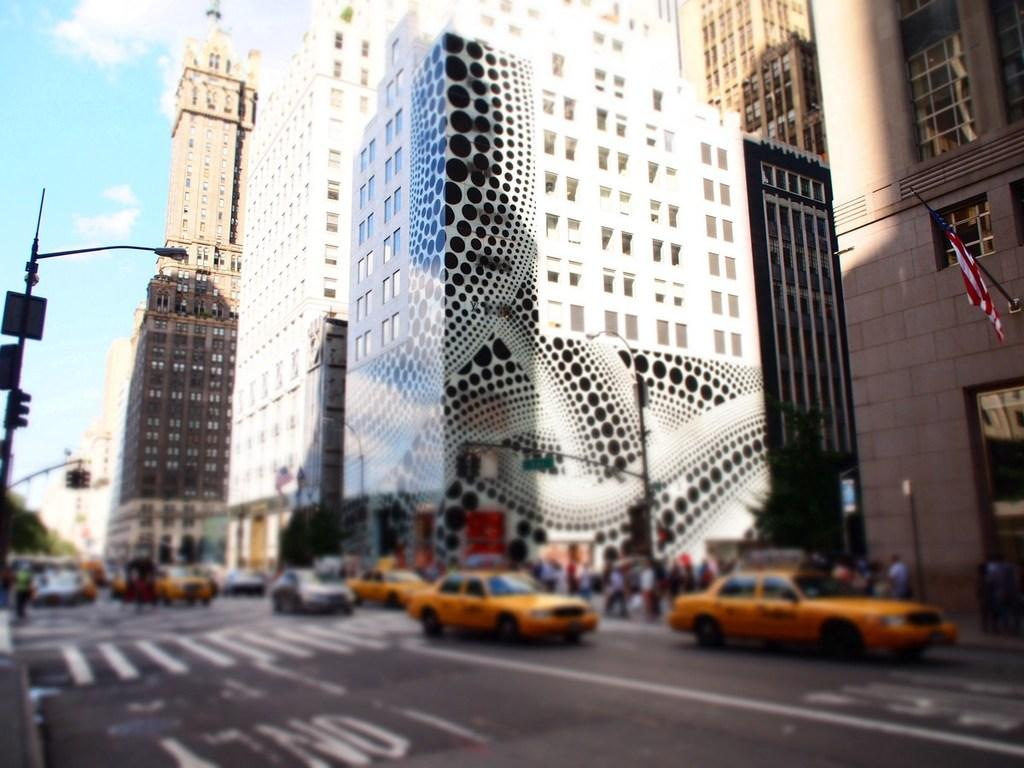What is the main feature of the image? There is a road in the image. What is happening on the road? There are cars on the road. What can be seen in the distance in the image? There are buildings in the background of the image. What type of thread is being used to create the verse on the plant in the image? There is no thread, verse, or plant present in the image. 